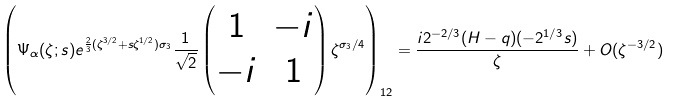<formula> <loc_0><loc_0><loc_500><loc_500>\left ( \Psi _ { \alpha } ( \zeta ; s ) e ^ { \frac { 2 } { 3 } ( \zeta ^ { 3 / 2 } + s \zeta ^ { 1 / 2 } ) \sigma _ { 3 } } \frac { 1 } { \sqrt { 2 } } \begin{pmatrix} 1 & - i \\ - i & 1 \end{pmatrix} \zeta ^ { \sigma _ { 3 } / 4 } \right ) _ { 1 2 } = \frac { i 2 ^ { - 2 / 3 } ( H - q ) ( - 2 ^ { 1 / 3 } s ) } { \zeta } + O ( \zeta ^ { - 3 / 2 } )</formula> 